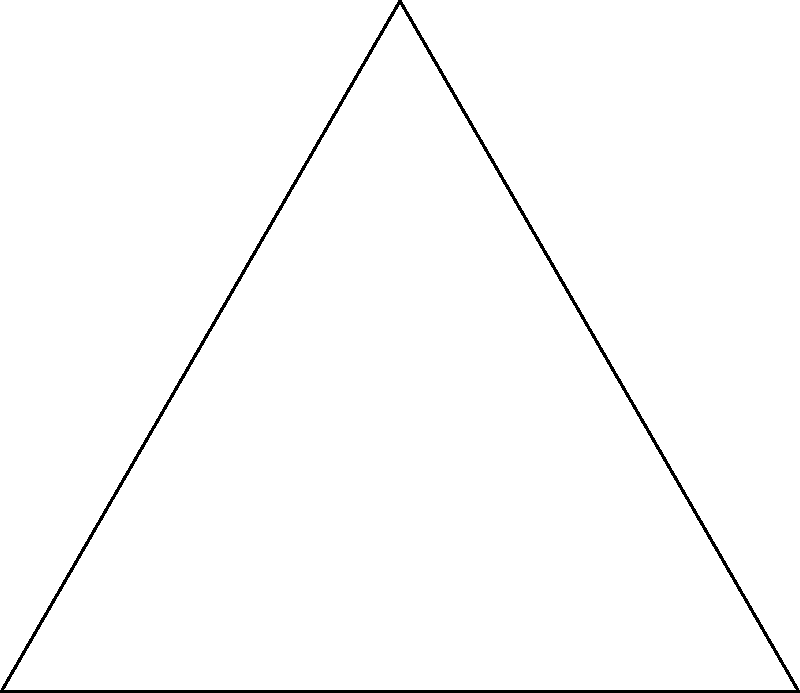In the Dharma Initiative logo from "Lost", an octagon is inscribed within a circle. If the central angle $\theta$ subtends one side of the octagon, what is the measure of $\theta$ in degrees? To find the measure of the central angle $\theta$ that subtends one side of the octagon in the Dharma Initiative logo, we can follow these steps:

1. Recall that a regular octagon has 8 equal sides.

2. The central angles of a regular polygon form a complete circle, which is 360°.

3. Since there are 8 sides, there are also 8 equal central angles.

4. To find the measure of one central angle, we divide the total degrees in a circle by the number of sides:

   $$\theta = \frac{360°}{8} = 45°$$

5. Therefore, the central angle $\theta$ that subtends one side of the octagon measures 45°.

This angle is significant in the show "Lost" as the Dharma Initiative logo appears frequently, and understanding its geometry adds to the appreciation of the show's intricate symbolism.
Answer: 45° 